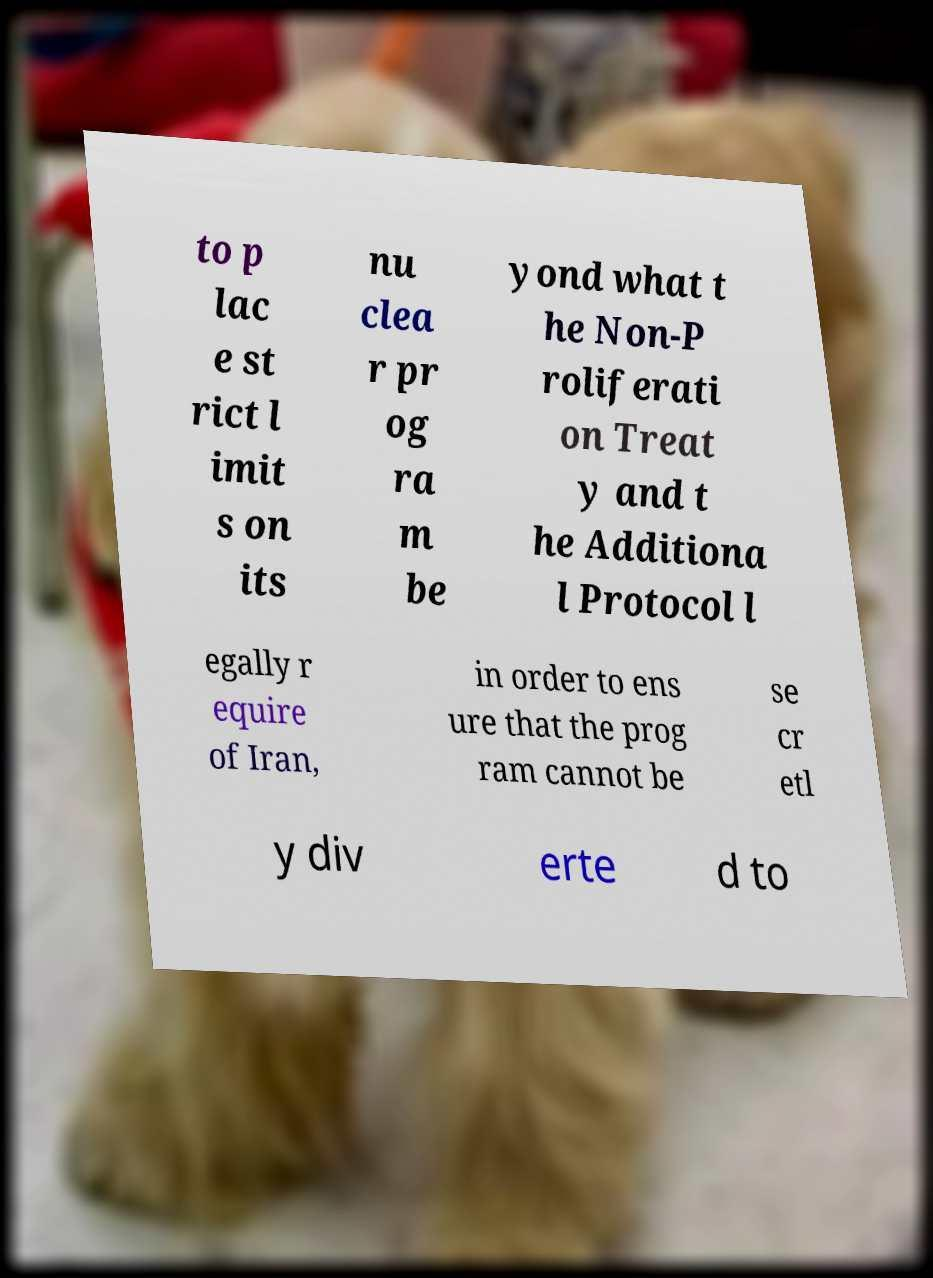Could you assist in decoding the text presented in this image and type it out clearly? to p lac e st rict l imit s on its nu clea r pr og ra m be yond what t he Non-P roliferati on Treat y and t he Additiona l Protocol l egally r equire of Iran, in order to ens ure that the prog ram cannot be se cr etl y div erte d to 